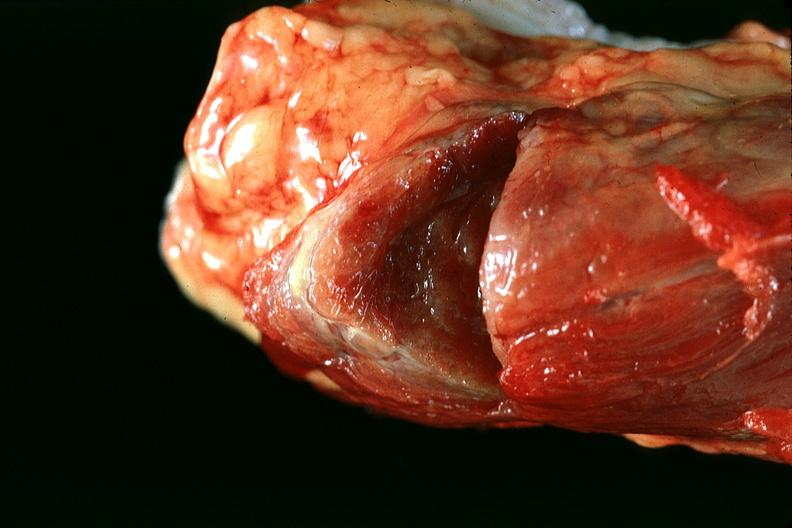what does this image show?
Answer the question using a single word or phrase. Thyroid 